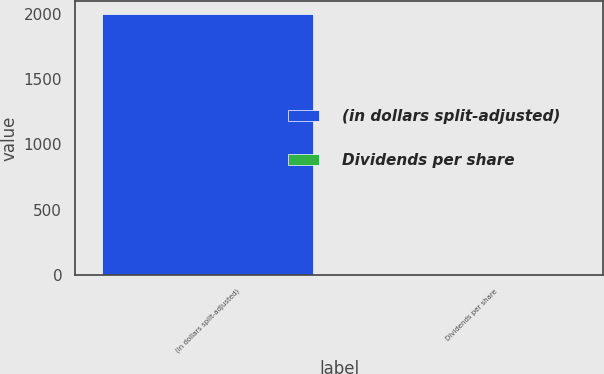Convert chart. <chart><loc_0><loc_0><loc_500><loc_500><bar_chart><fcel>(in dollars split-adjusted)<fcel>Dividends per share<nl><fcel>1996<fcel>0.4<nl></chart> 